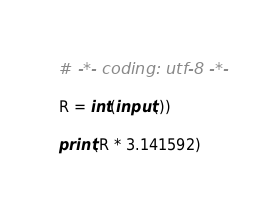Convert code to text. <code><loc_0><loc_0><loc_500><loc_500><_Python_># -*- coding: utf-8 -*-

R = int(input())

print(R * 3.141592)
</code> 